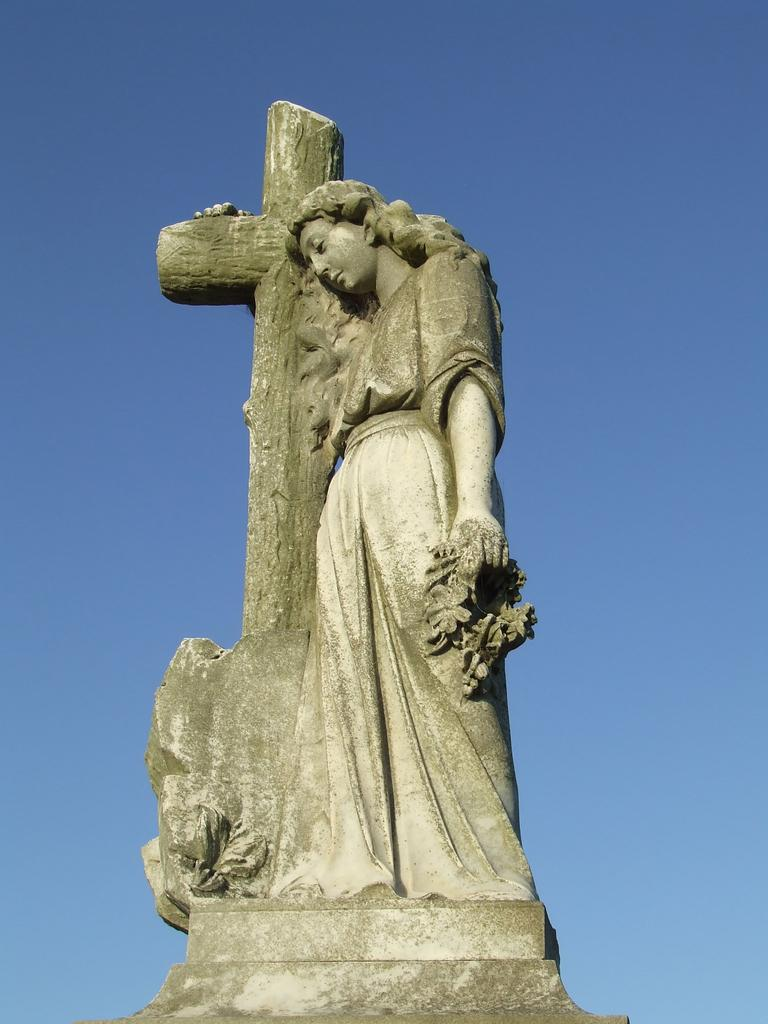What is the main subject of the image? There is a statue of a human in the image. What can be seen in the background of the image? The sky is blue in the background of the image. Where is the rabbit hiding in the image? There is no rabbit present in the image. Can you see any goldfish swimming in the sky? There are no goldfish visible in the image, and the sky is blue, not filled with water for fish to swim in. 